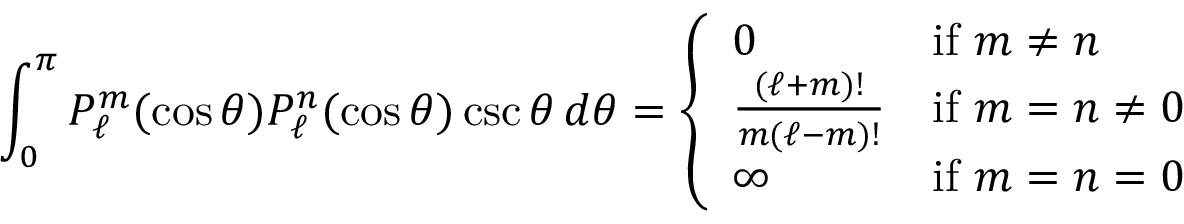Convert formula to latex. <formula><loc_0><loc_0><loc_500><loc_500>\int _ { 0 } ^ { \pi } P _ { \ell } ^ { m } ( \cos \theta ) P _ { \ell } ^ { n } ( \cos \theta ) \csc \theta \, d \theta = { \left \{ \begin{array} { l l } { 0 } & { { i f } m \neq n } \\ { { \frac { ( \ell + m ) ! } { m ( \ell - m ) ! } } } & { { i f } m = n \neq 0 } \\ { \infty } & { { i f } m = n = 0 } \end{array} }</formula> 